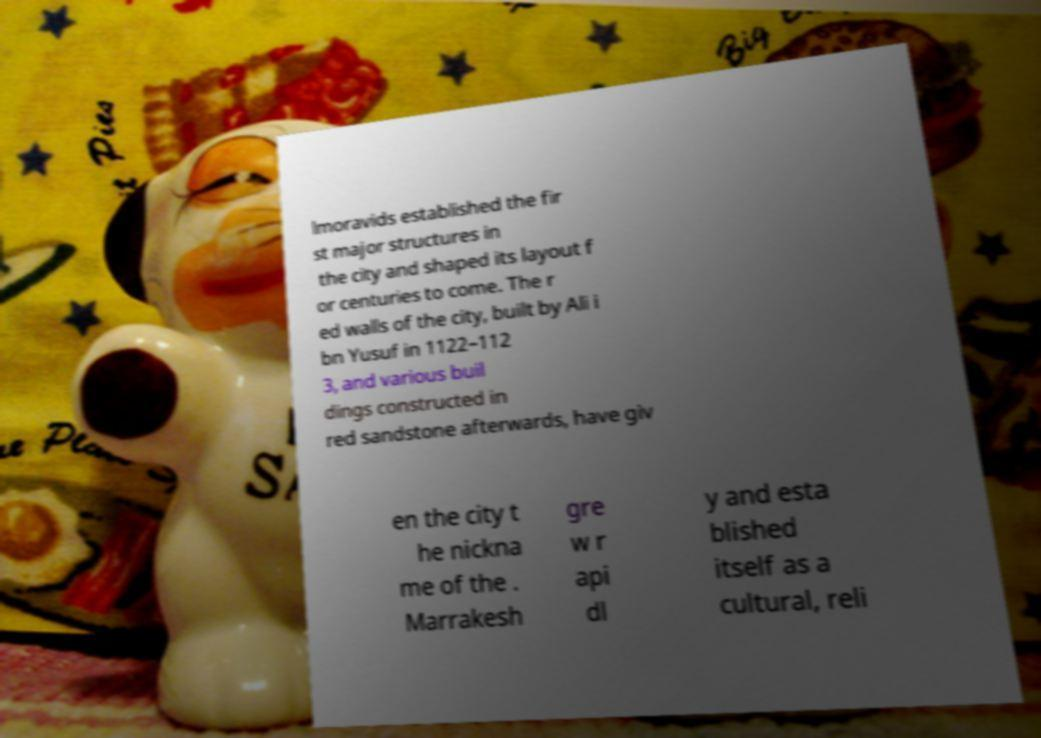There's text embedded in this image that I need extracted. Can you transcribe it verbatim? lmoravids established the fir st major structures in the city and shaped its layout f or centuries to come. The r ed walls of the city, built by Ali i bn Yusuf in 1122–112 3, and various buil dings constructed in red sandstone afterwards, have giv en the city t he nickna me of the . Marrakesh gre w r api dl y and esta blished itself as a cultural, reli 